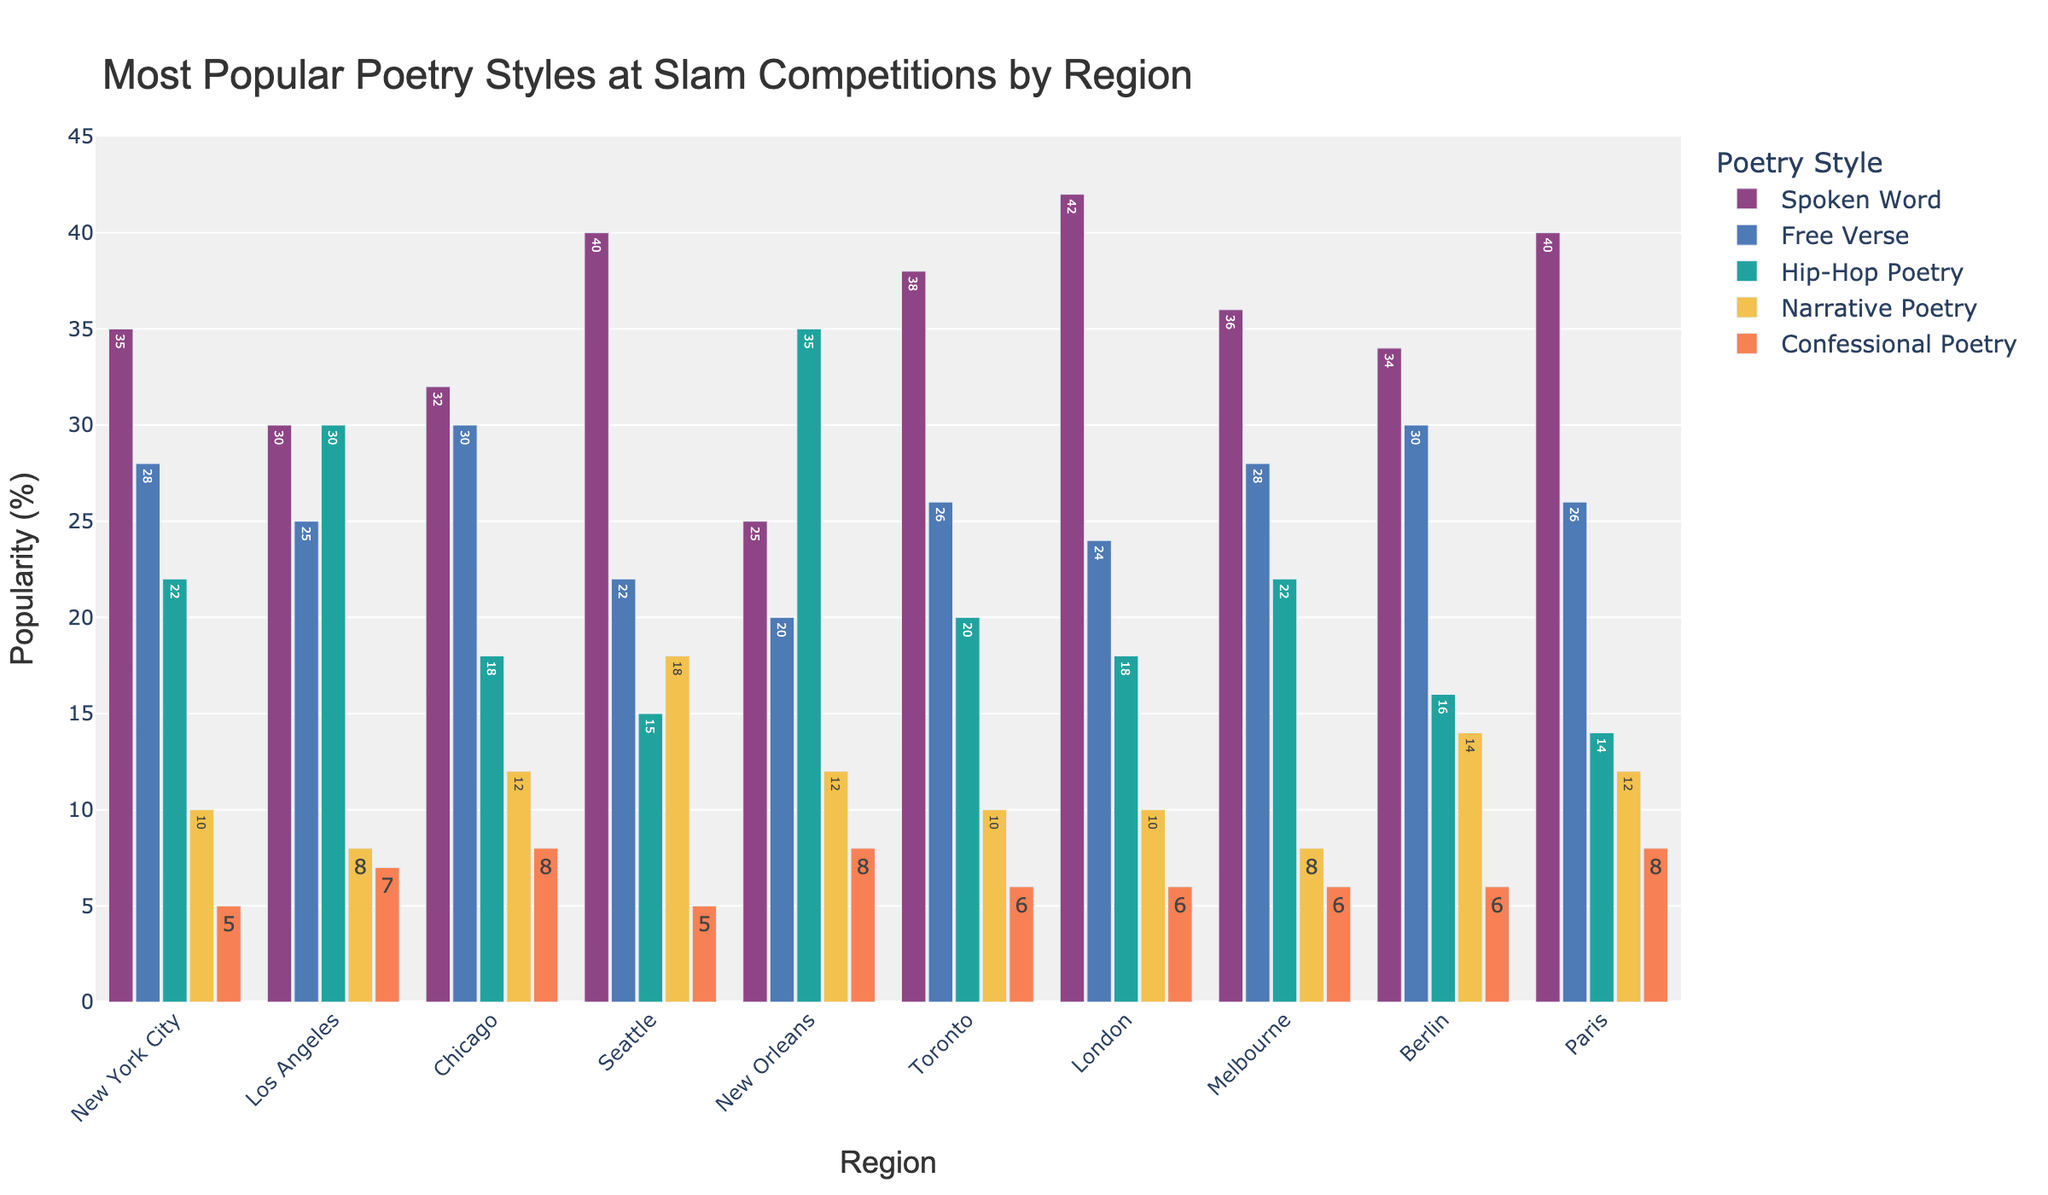Which region has the highest proportion of Spoken Word poetry? By visually examining the height of the bars representing Spoken Word in each region, we see that London has the tallest bar.
Answer: London What is the sum of Free Verse poetry proportions in New York City, Los Angeles, and Chicago? The proportions for Free Verse in New York City, Los Angeles, and Chicago are 28, 25, and 30, respectively. Adding them up: 28 + 25 + 30 = 83.
Answer: 83 Compare the popularity of Hip-Hop Poetry between New Orleans and Chicago. Which region has a higher value? By looking at the height of the bars for Hip-Hop Poetry, New Orleans has a value of 35, whereas Chicago has a value of 18. Therefore, New Orleans has a higher proportion of Hip-Hop Poetry.
Answer: New Orleans Which poetry style is least popular in Toronto? By observing the bars for Toronto, we see that Confessional Poetry has the smallest height, indicating it is the least popular.
Answer: Confessional Poetry How much greater is the proportion of Narrative Poetry in Seattle compared to Los Angeles? Seattle's proportion for Narrative Poetry is 18, while Los Angeles's is 8. The difference is calculated as 18 - 8, which equals 10.
Answer: 10 What are the average proportions of Hip-Hop Poetry across all regions? Summing up the values of Hip-Hop Poetry for all regions (22 + 30 + 18 + 15 + 35 + 20 + 18 + 22 + 16 + 14) gives 210. There are 10 regions, so the average is 210/10 = 21.
Answer: 21 In which region is Narrative Poetry most popular? By examining the height of the bars for Narrative Poetry in each region, we see that Seattle has the tallest bar at 18.
Answer: Seattle Which three regions have the highest proportions of Spoken Word poetry? By checking the heights of the bars for Spoken Word, the top three proportions are in London (42), Paris (40), and Seattle (40).
Answer: London, Paris, Seattle Is Free Verse more popular in Berlin or Los Angeles? Comparing the height of the Free Verse bars, Berlin has a value of 30, while Los Angeles has a value of 25. Therefore, Free Verse is more popular in Berlin.
Answer: Berlin What is the total count of Confessional Poetry proportions across New Orleans and Paris? The proportions for Confessional Poetry in New Orleans and Paris are both 8. Adding them together: 8 + 8 = 16.
Answer: 16 